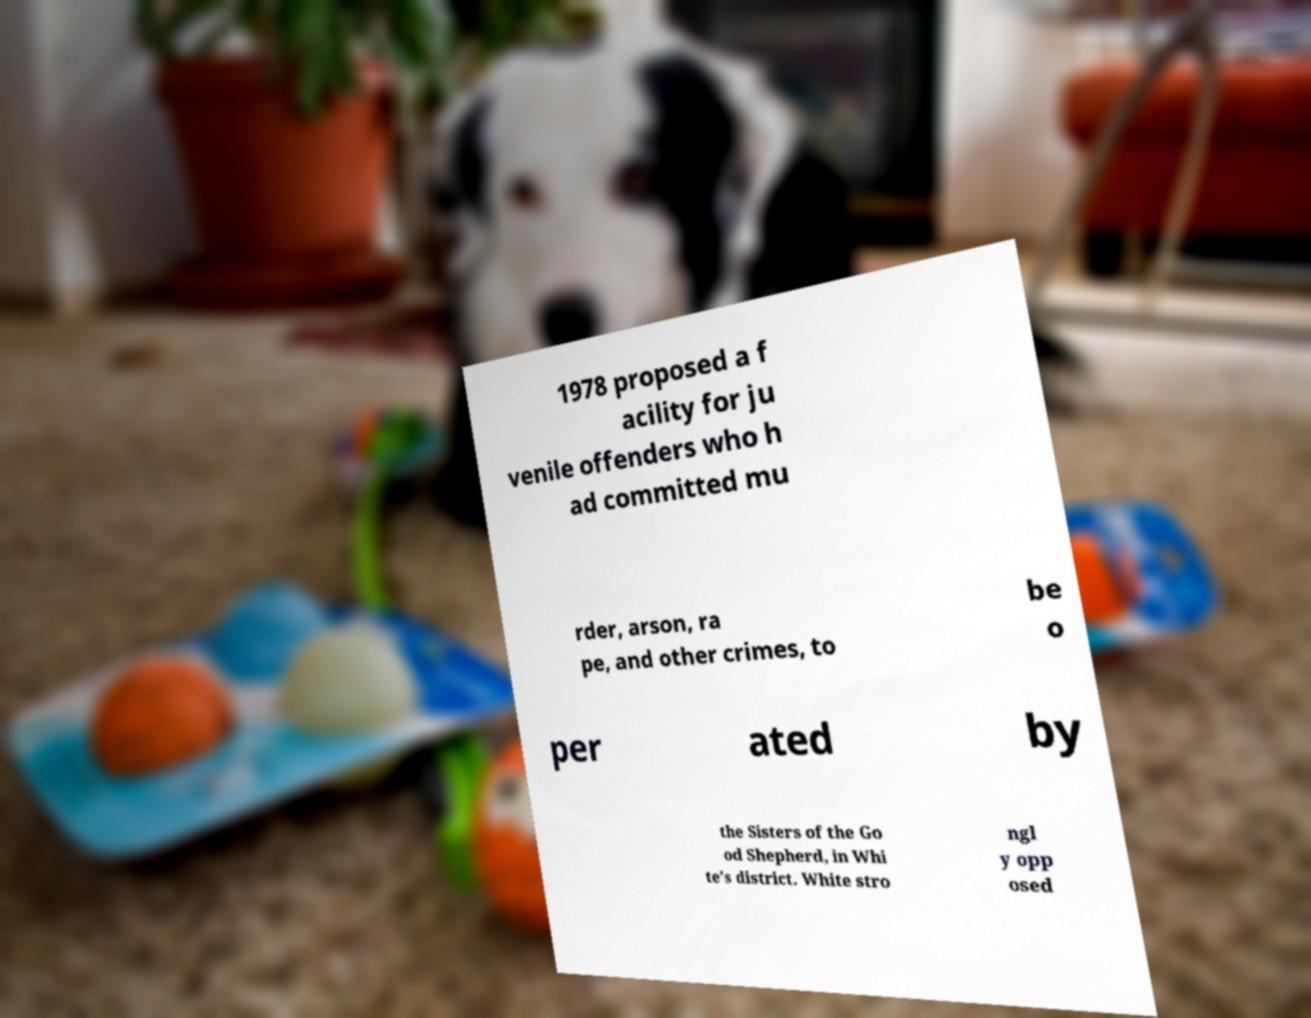Can you read and provide the text displayed in the image?This photo seems to have some interesting text. Can you extract and type it out for me? 1978 proposed a f acility for ju venile offenders who h ad committed mu rder, arson, ra pe, and other crimes, to be o per ated by the Sisters of the Go od Shepherd, in Whi te's district. White stro ngl y opp osed 